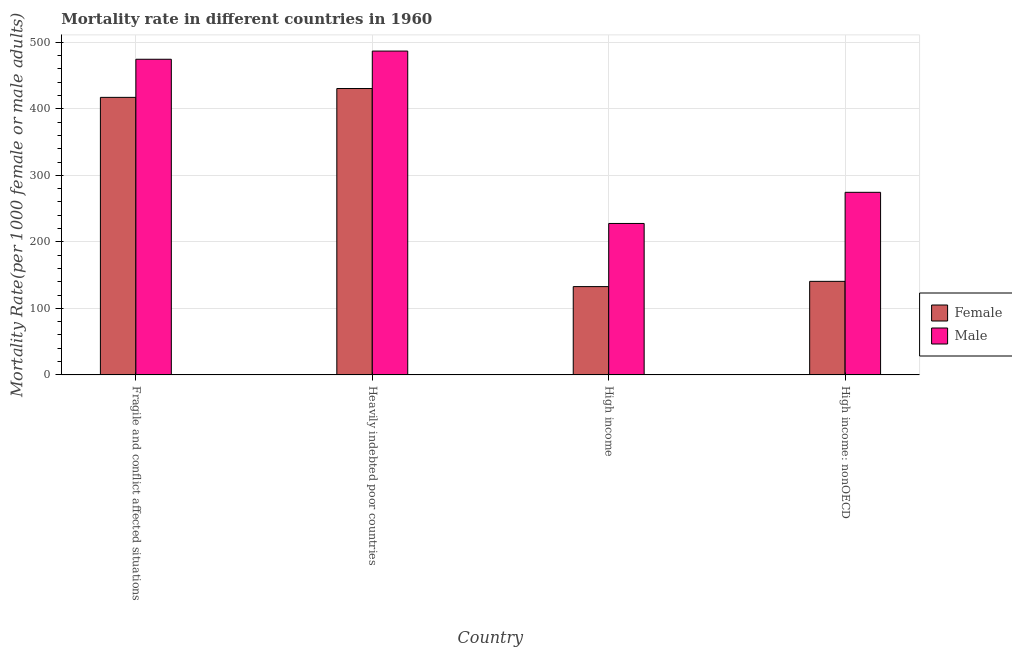How many groups of bars are there?
Offer a terse response. 4. Are the number of bars per tick equal to the number of legend labels?
Offer a very short reply. Yes. What is the label of the 3rd group of bars from the left?
Give a very brief answer. High income. In how many cases, is the number of bars for a given country not equal to the number of legend labels?
Your response must be concise. 0. What is the male mortality rate in Heavily indebted poor countries?
Give a very brief answer. 486.79. Across all countries, what is the maximum female mortality rate?
Your answer should be compact. 430.49. Across all countries, what is the minimum male mortality rate?
Ensure brevity in your answer.  227.66. In which country was the female mortality rate maximum?
Your response must be concise. Heavily indebted poor countries. In which country was the female mortality rate minimum?
Your answer should be very brief. High income. What is the total male mortality rate in the graph?
Keep it short and to the point. 1463.39. What is the difference between the male mortality rate in Heavily indebted poor countries and that in High income?
Keep it short and to the point. 259.13. What is the difference between the male mortality rate in High income: nonOECD and the female mortality rate in High income?
Make the answer very short. 141.71. What is the average female mortality rate per country?
Offer a terse response. 280.27. What is the difference between the male mortality rate and female mortality rate in Fragile and conflict affected situations?
Make the answer very short. 57.27. In how many countries, is the female mortality rate greater than 120 ?
Your response must be concise. 4. What is the ratio of the female mortality rate in Fragile and conflict affected situations to that in Heavily indebted poor countries?
Your answer should be very brief. 0.97. Is the difference between the female mortality rate in Heavily indebted poor countries and High income greater than the difference between the male mortality rate in Heavily indebted poor countries and High income?
Provide a succinct answer. Yes. What is the difference between the highest and the second highest male mortality rate?
Your answer should be compact. 12.31. What is the difference between the highest and the lowest female mortality rate?
Make the answer very short. 297.73. In how many countries, is the female mortality rate greater than the average female mortality rate taken over all countries?
Your answer should be very brief. 2. What does the 2nd bar from the right in Fragile and conflict affected situations represents?
Provide a succinct answer. Female. How many bars are there?
Your answer should be compact. 8. How many countries are there in the graph?
Provide a succinct answer. 4. What is the difference between two consecutive major ticks on the Y-axis?
Give a very brief answer. 100. Are the values on the major ticks of Y-axis written in scientific E-notation?
Your response must be concise. No. Does the graph contain grids?
Give a very brief answer. Yes. How are the legend labels stacked?
Ensure brevity in your answer.  Vertical. What is the title of the graph?
Provide a short and direct response. Mortality rate in different countries in 1960. What is the label or title of the X-axis?
Offer a terse response. Country. What is the label or title of the Y-axis?
Offer a very short reply. Mortality Rate(per 1000 female or male adults). What is the Mortality Rate(per 1000 female or male adults) in Female in Fragile and conflict affected situations?
Offer a very short reply. 417.21. What is the Mortality Rate(per 1000 female or male adults) in Male in Fragile and conflict affected situations?
Ensure brevity in your answer.  474.48. What is the Mortality Rate(per 1000 female or male adults) of Female in Heavily indebted poor countries?
Keep it short and to the point. 430.49. What is the Mortality Rate(per 1000 female or male adults) in Male in Heavily indebted poor countries?
Your answer should be compact. 486.79. What is the Mortality Rate(per 1000 female or male adults) in Female in High income?
Your answer should be very brief. 132.75. What is the Mortality Rate(per 1000 female or male adults) of Male in High income?
Give a very brief answer. 227.66. What is the Mortality Rate(per 1000 female or male adults) in Female in High income: nonOECD?
Provide a short and direct response. 140.64. What is the Mortality Rate(per 1000 female or male adults) in Male in High income: nonOECD?
Your answer should be very brief. 274.46. Across all countries, what is the maximum Mortality Rate(per 1000 female or male adults) in Female?
Make the answer very short. 430.49. Across all countries, what is the maximum Mortality Rate(per 1000 female or male adults) in Male?
Your response must be concise. 486.79. Across all countries, what is the minimum Mortality Rate(per 1000 female or male adults) in Female?
Offer a very short reply. 132.75. Across all countries, what is the minimum Mortality Rate(per 1000 female or male adults) of Male?
Offer a terse response. 227.66. What is the total Mortality Rate(per 1000 female or male adults) of Female in the graph?
Make the answer very short. 1121.09. What is the total Mortality Rate(per 1000 female or male adults) of Male in the graph?
Make the answer very short. 1463.39. What is the difference between the Mortality Rate(per 1000 female or male adults) of Female in Fragile and conflict affected situations and that in Heavily indebted poor countries?
Provide a succinct answer. -13.28. What is the difference between the Mortality Rate(per 1000 female or male adults) in Male in Fragile and conflict affected situations and that in Heavily indebted poor countries?
Give a very brief answer. -12.31. What is the difference between the Mortality Rate(per 1000 female or male adults) in Female in Fragile and conflict affected situations and that in High income?
Keep it short and to the point. 284.45. What is the difference between the Mortality Rate(per 1000 female or male adults) in Male in Fragile and conflict affected situations and that in High income?
Your answer should be compact. 246.82. What is the difference between the Mortality Rate(per 1000 female or male adults) in Female in Fragile and conflict affected situations and that in High income: nonOECD?
Offer a very short reply. 276.56. What is the difference between the Mortality Rate(per 1000 female or male adults) in Male in Fragile and conflict affected situations and that in High income: nonOECD?
Provide a short and direct response. 200.02. What is the difference between the Mortality Rate(per 1000 female or male adults) in Female in Heavily indebted poor countries and that in High income?
Offer a very short reply. 297.73. What is the difference between the Mortality Rate(per 1000 female or male adults) in Male in Heavily indebted poor countries and that in High income?
Provide a short and direct response. 259.13. What is the difference between the Mortality Rate(per 1000 female or male adults) of Female in Heavily indebted poor countries and that in High income: nonOECD?
Your response must be concise. 289.84. What is the difference between the Mortality Rate(per 1000 female or male adults) of Male in Heavily indebted poor countries and that in High income: nonOECD?
Your response must be concise. 212.33. What is the difference between the Mortality Rate(per 1000 female or male adults) in Female in High income and that in High income: nonOECD?
Your answer should be compact. -7.89. What is the difference between the Mortality Rate(per 1000 female or male adults) in Male in High income and that in High income: nonOECD?
Provide a short and direct response. -46.8. What is the difference between the Mortality Rate(per 1000 female or male adults) in Female in Fragile and conflict affected situations and the Mortality Rate(per 1000 female or male adults) in Male in Heavily indebted poor countries?
Your answer should be compact. -69.59. What is the difference between the Mortality Rate(per 1000 female or male adults) in Female in Fragile and conflict affected situations and the Mortality Rate(per 1000 female or male adults) in Male in High income?
Ensure brevity in your answer.  189.55. What is the difference between the Mortality Rate(per 1000 female or male adults) of Female in Fragile and conflict affected situations and the Mortality Rate(per 1000 female or male adults) of Male in High income: nonOECD?
Your answer should be very brief. 142.74. What is the difference between the Mortality Rate(per 1000 female or male adults) of Female in Heavily indebted poor countries and the Mortality Rate(per 1000 female or male adults) of Male in High income?
Offer a terse response. 202.83. What is the difference between the Mortality Rate(per 1000 female or male adults) of Female in Heavily indebted poor countries and the Mortality Rate(per 1000 female or male adults) of Male in High income: nonOECD?
Keep it short and to the point. 156.02. What is the difference between the Mortality Rate(per 1000 female or male adults) of Female in High income and the Mortality Rate(per 1000 female or male adults) of Male in High income: nonOECD?
Give a very brief answer. -141.71. What is the average Mortality Rate(per 1000 female or male adults) in Female per country?
Provide a short and direct response. 280.27. What is the average Mortality Rate(per 1000 female or male adults) in Male per country?
Your response must be concise. 365.85. What is the difference between the Mortality Rate(per 1000 female or male adults) of Female and Mortality Rate(per 1000 female or male adults) of Male in Fragile and conflict affected situations?
Ensure brevity in your answer.  -57.27. What is the difference between the Mortality Rate(per 1000 female or male adults) in Female and Mortality Rate(per 1000 female or male adults) in Male in Heavily indebted poor countries?
Offer a very short reply. -56.3. What is the difference between the Mortality Rate(per 1000 female or male adults) of Female and Mortality Rate(per 1000 female or male adults) of Male in High income?
Give a very brief answer. -94.9. What is the difference between the Mortality Rate(per 1000 female or male adults) of Female and Mortality Rate(per 1000 female or male adults) of Male in High income: nonOECD?
Make the answer very short. -133.82. What is the ratio of the Mortality Rate(per 1000 female or male adults) of Female in Fragile and conflict affected situations to that in Heavily indebted poor countries?
Your answer should be very brief. 0.97. What is the ratio of the Mortality Rate(per 1000 female or male adults) of Male in Fragile and conflict affected situations to that in Heavily indebted poor countries?
Keep it short and to the point. 0.97. What is the ratio of the Mortality Rate(per 1000 female or male adults) of Female in Fragile and conflict affected situations to that in High income?
Your answer should be compact. 3.14. What is the ratio of the Mortality Rate(per 1000 female or male adults) of Male in Fragile and conflict affected situations to that in High income?
Give a very brief answer. 2.08. What is the ratio of the Mortality Rate(per 1000 female or male adults) of Female in Fragile and conflict affected situations to that in High income: nonOECD?
Make the answer very short. 2.97. What is the ratio of the Mortality Rate(per 1000 female or male adults) of Male in Fragile and conflict affected situations to that in High income: nonOECD?
Offer a terse response. 1.73. What is the ratio of the Mortality Rate(per 1000 female or male adults) of Female in Heavily indebted poor countries to that in High income?
Provide a short and direct response. 3.24. What is the ratio of the Mortality Rate(per 1000 female or male adults) of Male in Heavily indebted poor countries to that in High income?
Your answer should be compact. 2.14. What is the ratio of the Mortality Rate(per 1000 female or male adults) of Female in Heavily indebted poor countries to that in High income: nonOECD?
Give a very brief answer. 3.06. What is the ratio of the Mortality Rate(per 1000 female or male adults) of Male in Heavily indebted poor countries to that in High income: nonOECD?
Your response must be concise. 1.77. What is the ratio of the Mortality Rate(per 1000 female or male adults) of Female in High income to that in High income: nonOECD?
Give a very brief answer. 0.94. What is the ratio of the Mortality Rate(per 1000 female or male adults) of Male in High income to that in High income: nonOECD?
Provide a succinct answer. 0.83. What is the difference between the highest and the second highest Mortality Rate(per 1000 female or male adults) of Female?
Provide a succinct answer. 13.28. What is the difference between the highest and the second highest Mortality Rate(per 1000 female or male adults) in Male?
Provide a short and direct response. 12.31. What is the difference between the highest and the lowest Mortality Rate(per 1000 female or male adults) of Female?
Ensure brevity in your answer.  297.73. What is the difference between the highest and the lowest Mortality Rate(per 1000 female or male adults) of Male?
Give a very brief answer. 259.13. 